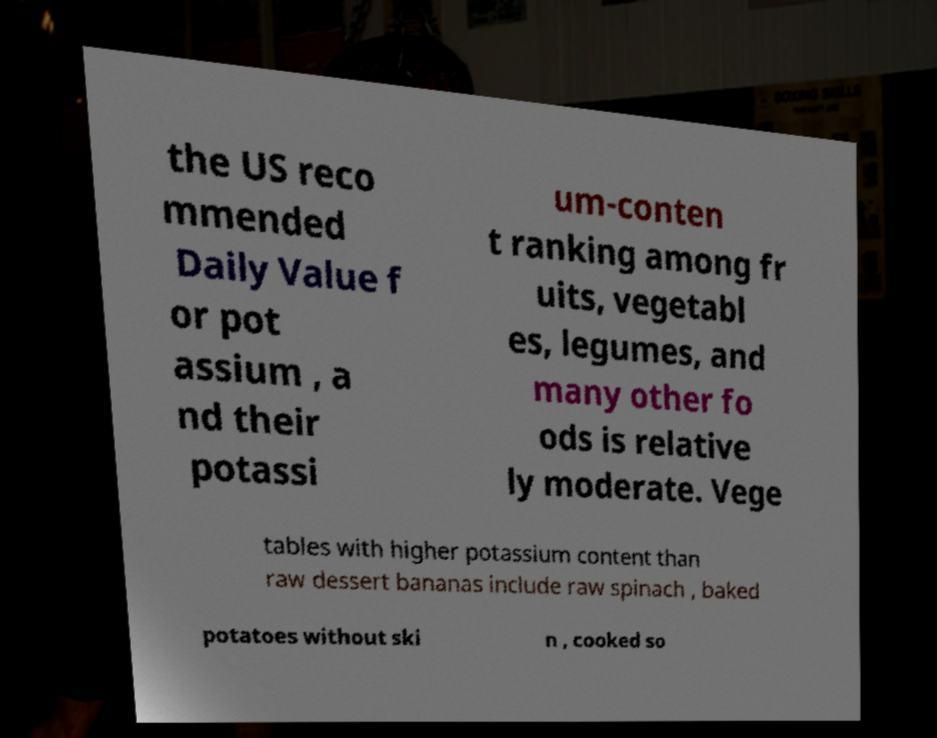What messages or text are displayed in this image? I need them in a readable, typed format. the US reco mmended Daily Value f or pot assium , a nd their potassi um-conten t ranking among fr uits, vegetabl es, legumes, and many other fo ods is relative ly moderate. Vege tables with higher potassium content than raw dessert bananas include raw spinach , baked potatoes without ski n , cooked so 